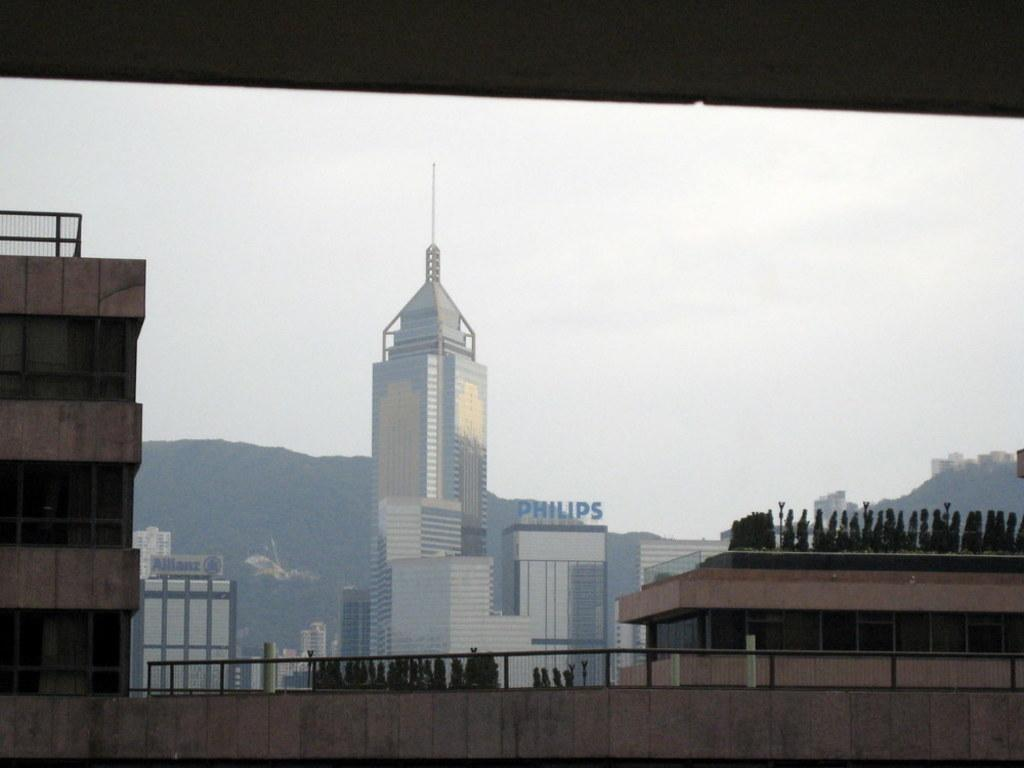What type of structures can be seen in the image? There are many buildings in the image. What other natural elements are present in the image? There are trees in the image. What can be seen in the distance in the image? There are hills visible in the background of the image. What is visible at the top of the image? The sky is visible at the top of the image. Where might this image have been taken? The image might have been clicked outside the city, given the presence of trees and hills. Can you tell me how many basketballs are visible on the trees in the image? There are no basketballs present in the image; it features buildings, trees, hills, and the sky. What type of apparel is being worn by the horse in the image? There is no horse present in the image, as it only contains buildings, trees, hills, and the sky. 